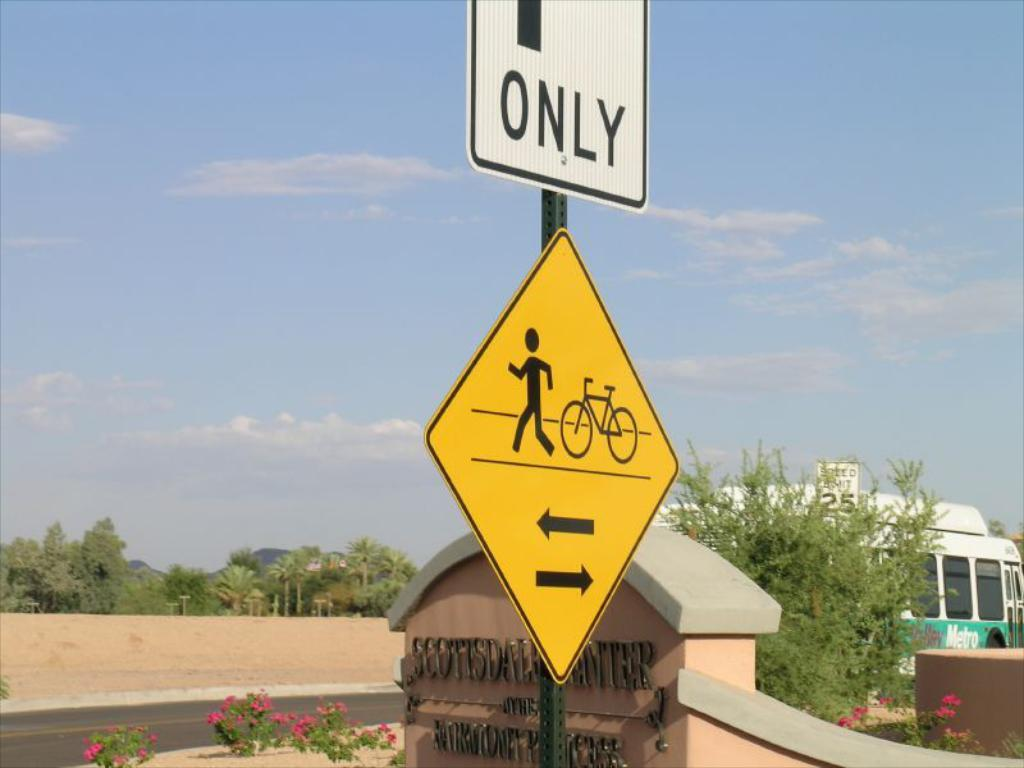<image>
Present a compact description of the photo's key features. Several street signs are in front of a sign for the Scottsdale Center. 